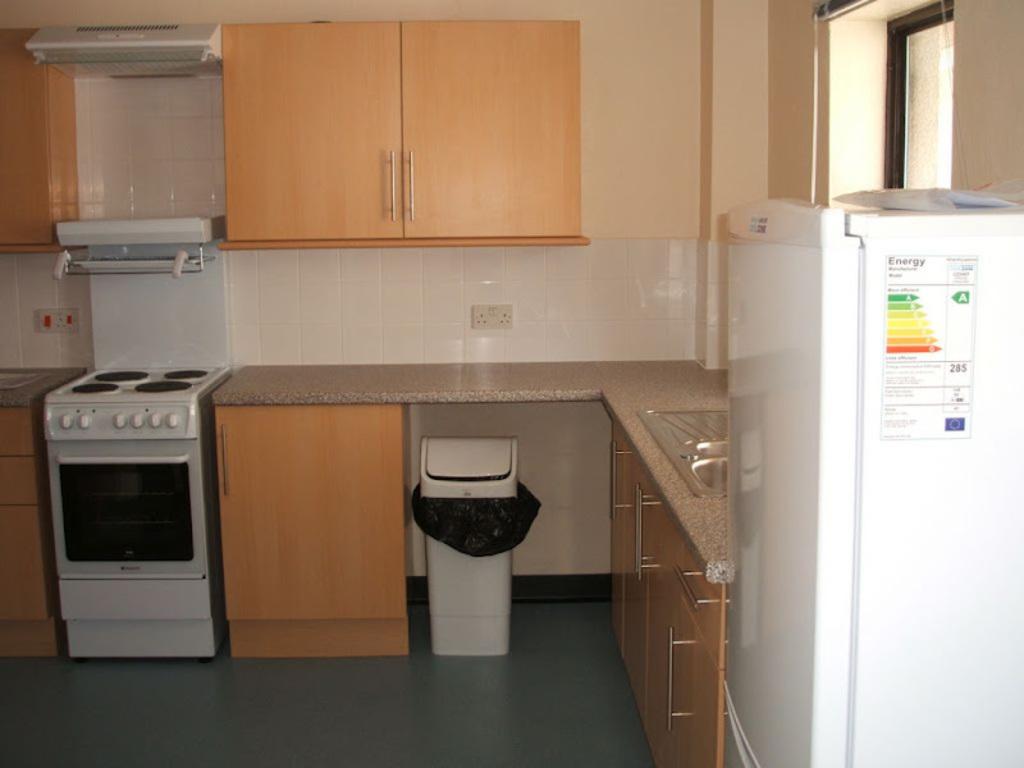What is the topic of the sticker on the refrigerator?
Provide a succinct answer. Energy. What´s on the oven?
Make the answer very short. Nothing. 